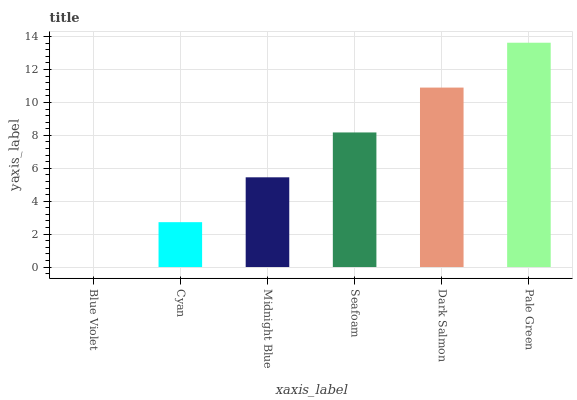Is Blue Violet the minimum?
Answer yes or no. Yes. Is Pale Green the maximum?
Answer yes or no. Yes. Is Cyan the minimum?
Answer yes or no. No. Is Cyan the maximum?
Answer yes or no. No. Is Cyan greater than Blue Violet?
Answer yes or no. Yes. Is Blue Violet less than Cyan?
Answer yes or no. Yes. Is Blue Violet greater than Cyan?
Answer yes or no. No. Is Cyan less than Blue Violet?
Answer yes or no. No. Is Seafoam the high median?
Answer yes or no. Yes. Is Midnight Blue the low median?
Answer yes or no. Yes. Is Cyan the high median?
Answer yes or no. No. Is Dark Salmon the low median?
Answer yes or no. No. 